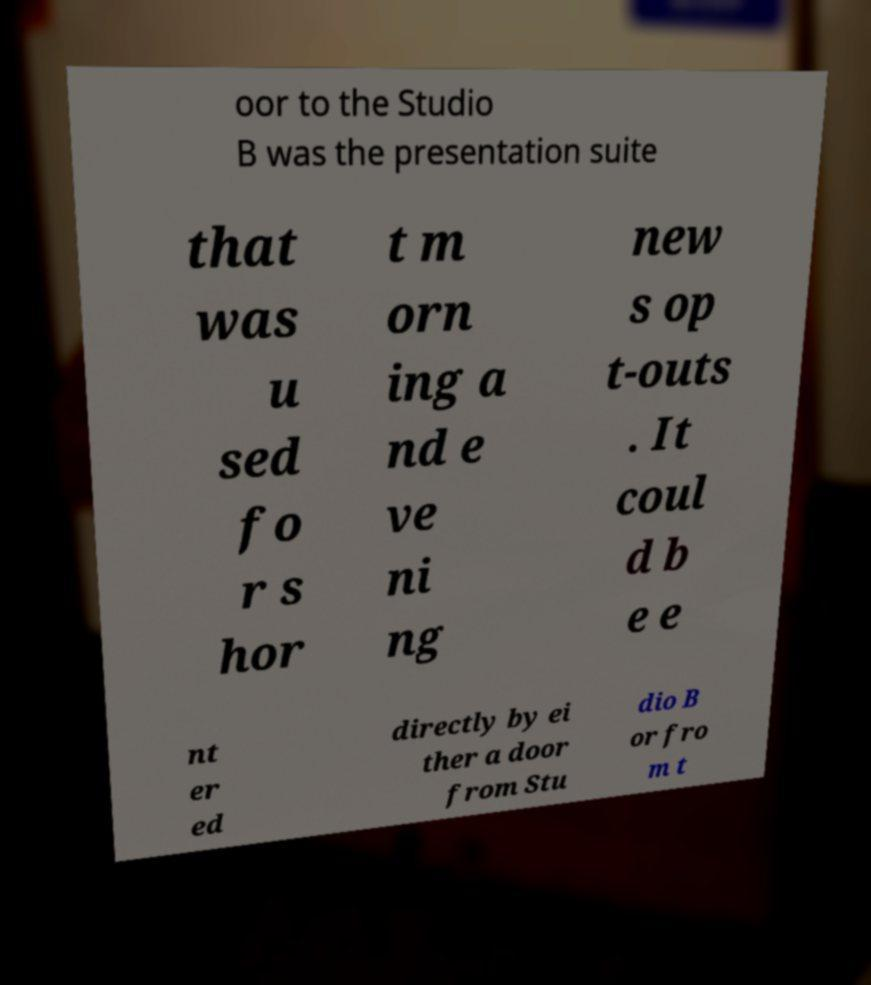Can you accurately transcribe the text from the provided image for me? oor to the Studio B was the presentation suite that was u sed fo r s hor t m orn ing a nd e ve ni ng new s op t-outs . It coul d b e e nt er ed directly by ei ther a door from Stu dio B or fro m t 